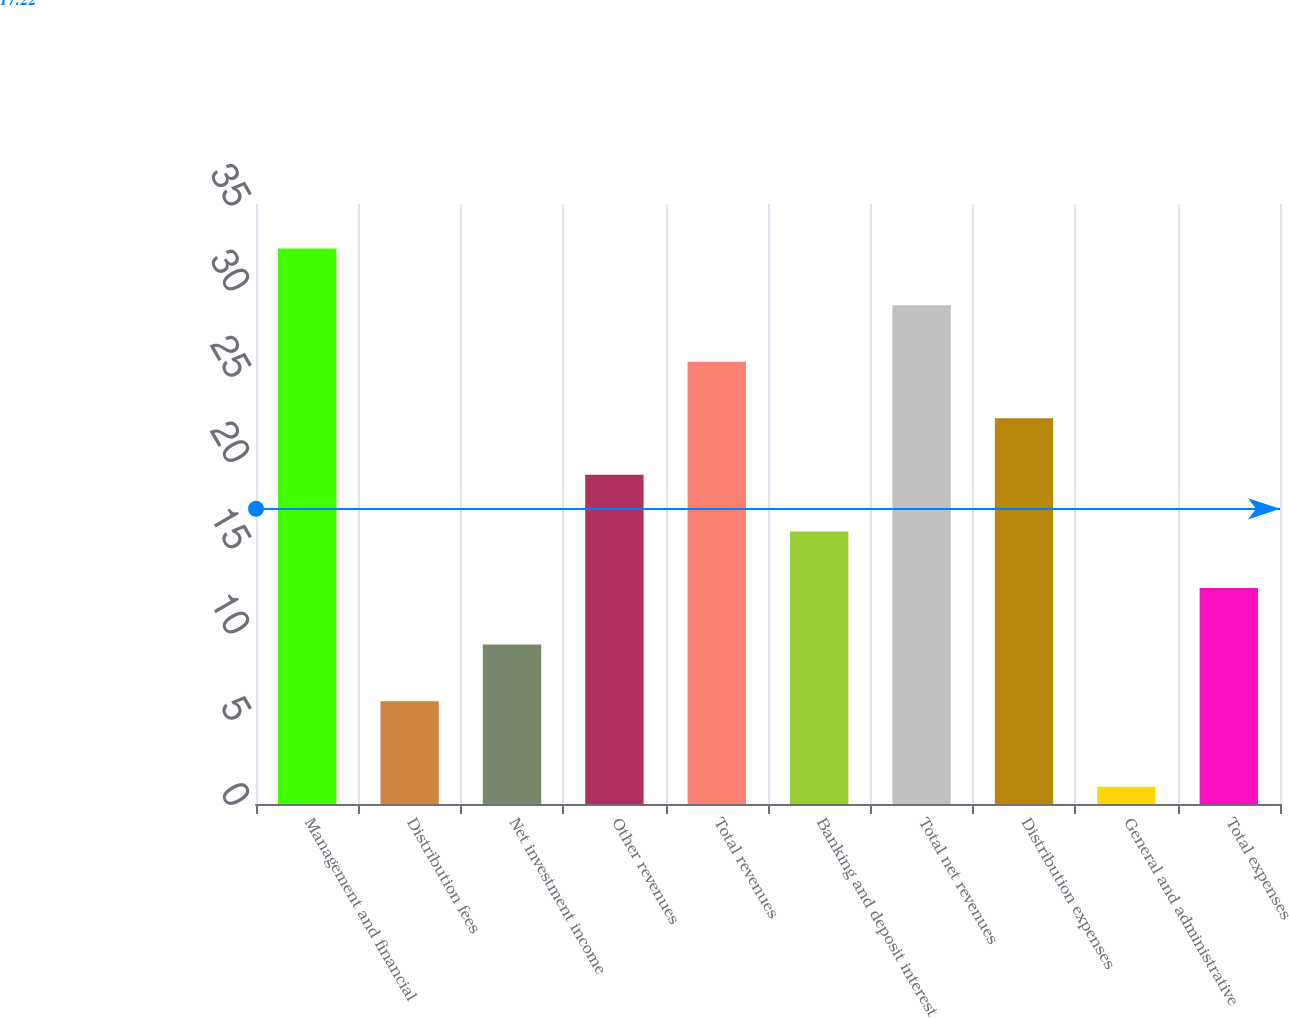Convert chart to OTSL. <chart><loc_0><loc_0><loc_500><loc_500><bar_chart><fcel>Management and financial<fcel>Distribution fees<fcel>Net investment income<fcel>Other revenues<fcel>Total revenues<fcel>Banking and deposit interest<fcel>Total net revenues<fcel>Distribution expenses<fcel>General and administrative<fcel>Total expenses<nl><fcel>32.4<fcel>6<fcel>9.3<fcel>19.2<fcel>25.8<fcel>15.9<fcel>29.1<fcel>22.5<fcel>1<fcel>12.6<nl></chart> 